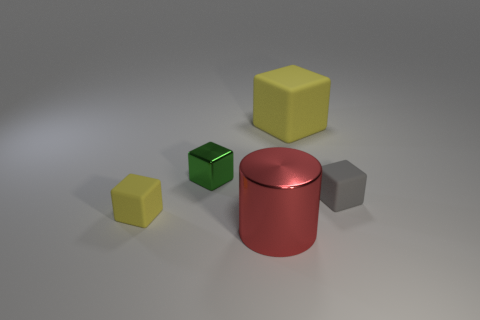Subtract all gray blocks. How many blocks are left? 3 Subtract all gray blocks. How many blocks are left? 3 Add 4 tiny gray blocks. How many objects exist? 9 Subtract all red blocks. Subtract all gray cylinders. How many blocks are left? 4 Subtract all cubes. How many objects are left? 1 Add 4 red rubber blocks. How many red rubber blocks exist? 4 Subtract 0 purple blocks. How many objects are left? 5 Subtract all big cubes. Subtract all large objects. How many objects are left? 2 Add 1 cubes. How many cubes are left? 5 